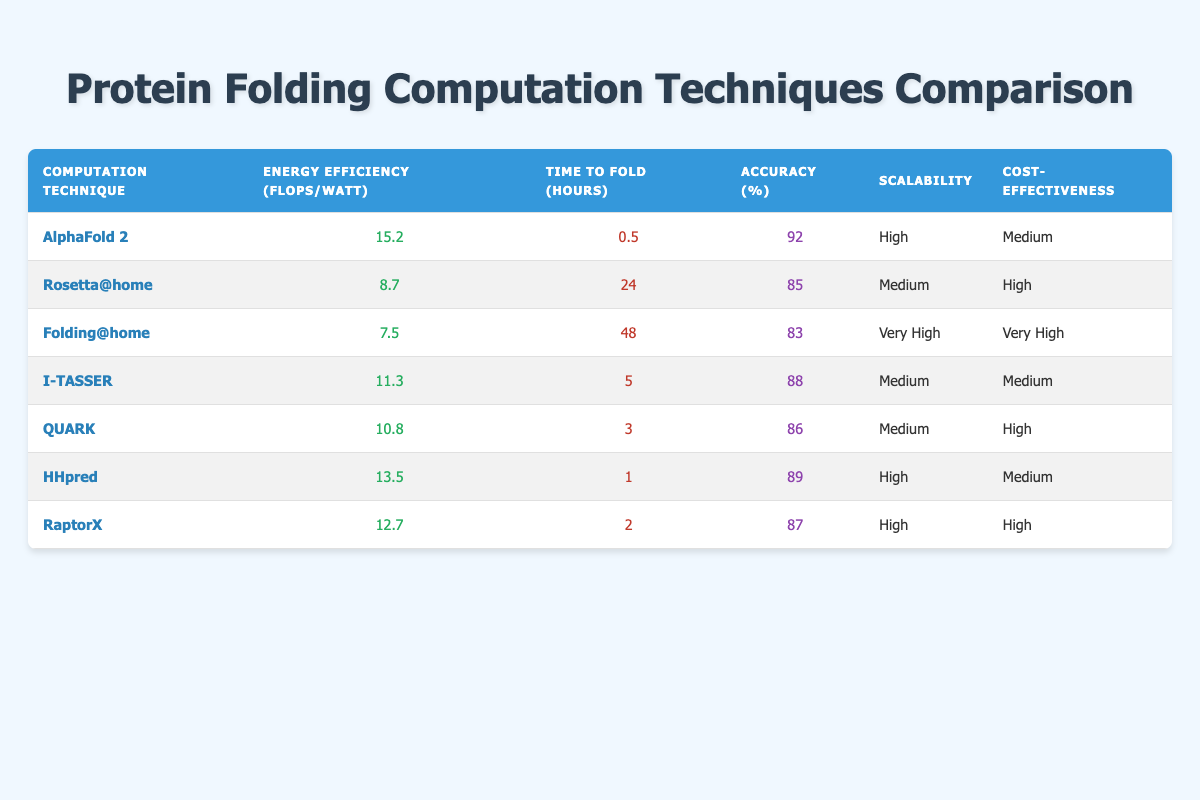What is the energy efficiency of AlphaFold 2? The table directly lists "15.2" under the "Energy Efficiency (FLOPS/Watt)" column for AlphaFold 2.
Answer: 15.2 Which computation technique has the highest accuracy? Scanning through the "Accuracy (%)" column, AlphaFold 2 has the highest value at 92%.
Answer: AlphaFold 2 What is the average time to fold for all the techniques listed? To find the average, sum the time values: (0.5 + 24 + 48 + 5 + 3 + 1 + 2) = 83.5 hours. Since there are 7 techniques, the average time is 83.5/7 = approximately 11.93 hours.
Answer: Approximately 11.93 hours Is Folding@home more cost-effective than HHpred? The "Cost-effectiveness" column shows that Folding@home is categorized as "Very High," while HHpred is rated as "Medium." Therefore, Folding@home is indeed more cost-effective.
Answer: Yes How many techniques have high scalability? The table lists three techniques with "High" scalability: AlphaFold 2, HHpred, and RaptorX, which makes a total of three techniques.
Answer: 3 Which technique takes the least time to fold and what is that time? The table shows that "HHpred" takes the least time with a duration of "1" hour.
Answer: HHpred; 1 hour What is the difference in energy efficiency between I-TASSER and RaptorX? From the table, I-TASSER has 11.3 FLOPS/Watt and RaptorX has 12.7 FLOPS/Watt. To find the difference, calculate 12.7 - 11.3 = 1.4.
Answer: 1.4 FLOPS/Watt Which computation technique has both high scalability and high cost-effectiveness? RaptorX meets both criteria, as it is listed under "High" for both "Scalability" and "Cost-effectiveness."
Answer: RaptorX What is the lowest accuracy percentage among the listed techniques? Scanning through the "Accuracy (%)" column, Folding@home has the lowest accuracy at 83%.
Answer: 83 